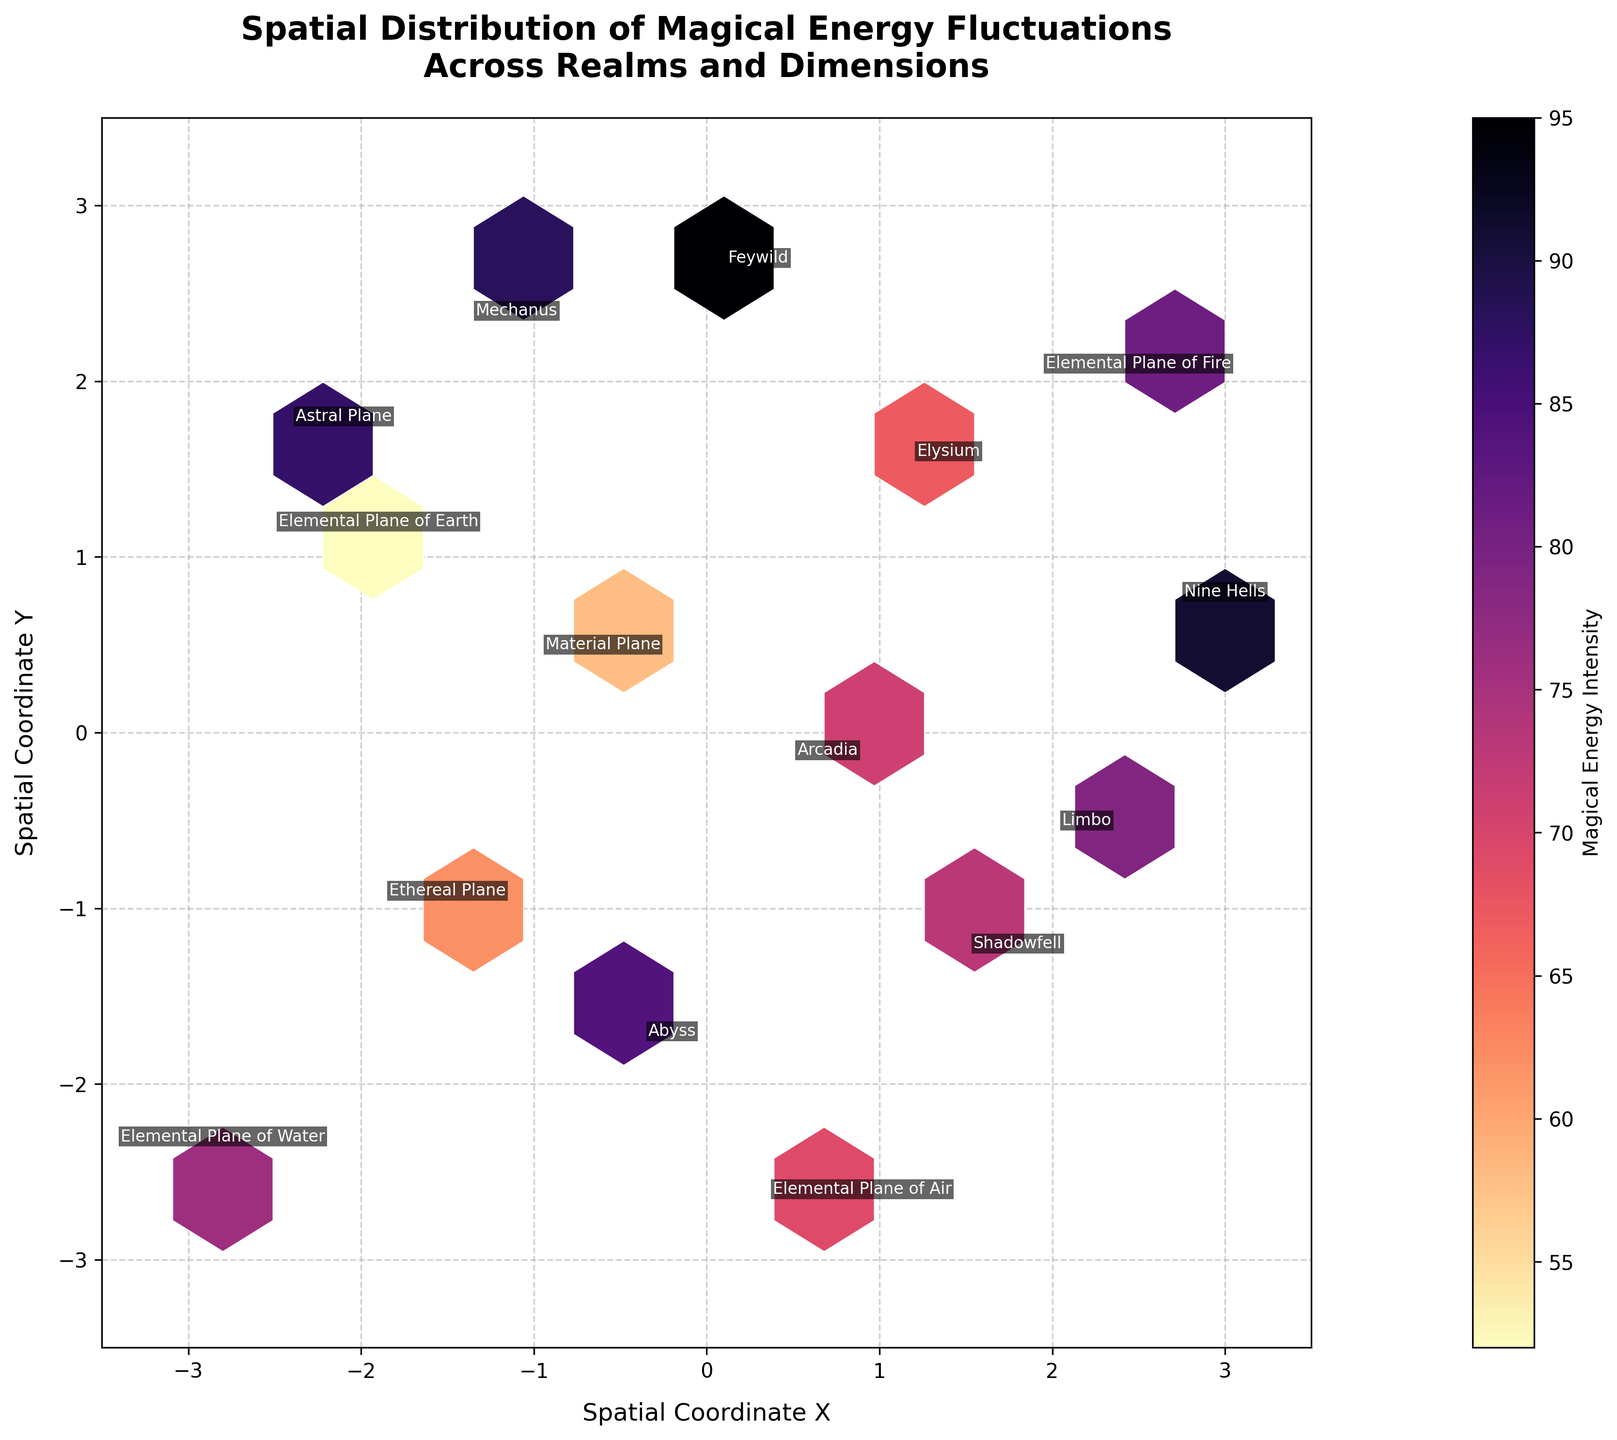What is the title of the plot? The title of the plot is usually placed at the top of the figure. In this case, it reads 'Spatial Distribution of Magical Energy Fluctuations Across Realms and Dimensions'.
Answer: Spatial Distribution of Magical Energy Fluctuations Across Realms and Dimensions What are the axes labels in the plot? Axes labels usually describe the data representation in the plot. Here, the labels are 'Spatial Coordinate X' for the x-axis and 'Spatial Coordinate Y' for the y-axis.
Answer: Spatial Coordinate X, Spatial Coordinate Y Which realm has the highest intensity of magical energy? To find the highest intensity, we need to look at the color scale or the annotations on the plot. The highest value is 95, which corresponds to 'Feywild'.
Answer: Feywild How many data points are represented in the plot? Each realm represents one data point. By counting the annotated realms in the plot, we have 14 data points.
Answer: 14 Which realm is located closest to the center (0,0)? The distance to the center (0,0) can be calculated visually or by looking at the coordinates. 'Arcadia' with coordinates (0.7, -0.1) is closest to the center.
Answer: Arcadia How does the intensity of the Nine Hells compare with the Ethereal Plane? The Nine Hells has an intensity of 91, while the Ethereal Plane has an intensity of 62. The intensity is higher in the Nine Hells.
Answer: Nine Hells has higher intensity Are there more realms with positive or negative Y coordinates? Count the number of realms with positive and negative y-values. Realms with positive Y coordinates (7), Realms with negative Y coordinates (7). There is an equal number.
Answer: Equal number What is the average intensity of the realms located in negative X coordinates? Realms located at negative X coordinates: Astral Plane (87), Ethereal Plane (62), Elemental Plane of Water (76), Elemental Plane of Earth (52), Mechanus (88). Average = (87+62+76+52+88)/5 = 73
Answer: 73 Which realm positioned in positive X coordinates has the lowest intensity? By examining the positive X coordinate realms, 'Elysium' has the lowest intensity with 67.
Answer: Elysium How does the energy fluctuation in Elysium compare with Limbo? Elysium's intensity is 67 and Limbo's intensity is 79, so Elysium has a lower energy fluctuation than Limbo.
Answer: Elysium has lower energy fluctuation What is the color indicating the highest magical energy intensity on the color bar? The highest intensity is indicated by the lightest color on the color bar (in magma_r colormap, it is yellow/white)
Answer: Yellow/White 